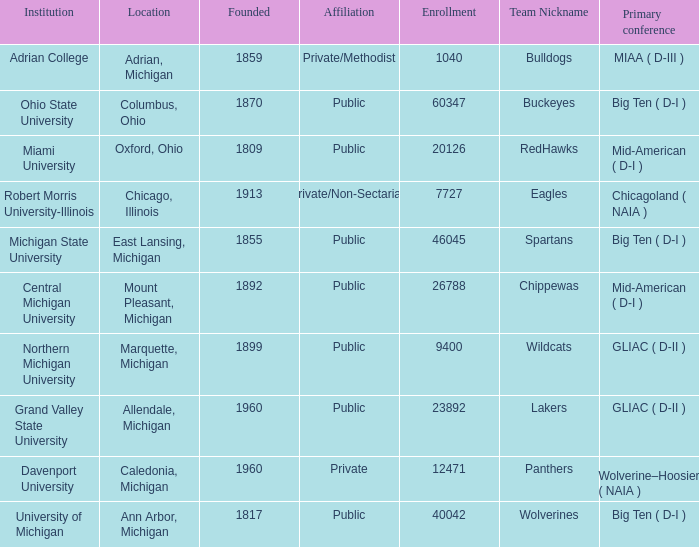What is the enrollment for the Redhawks? 1.0. 